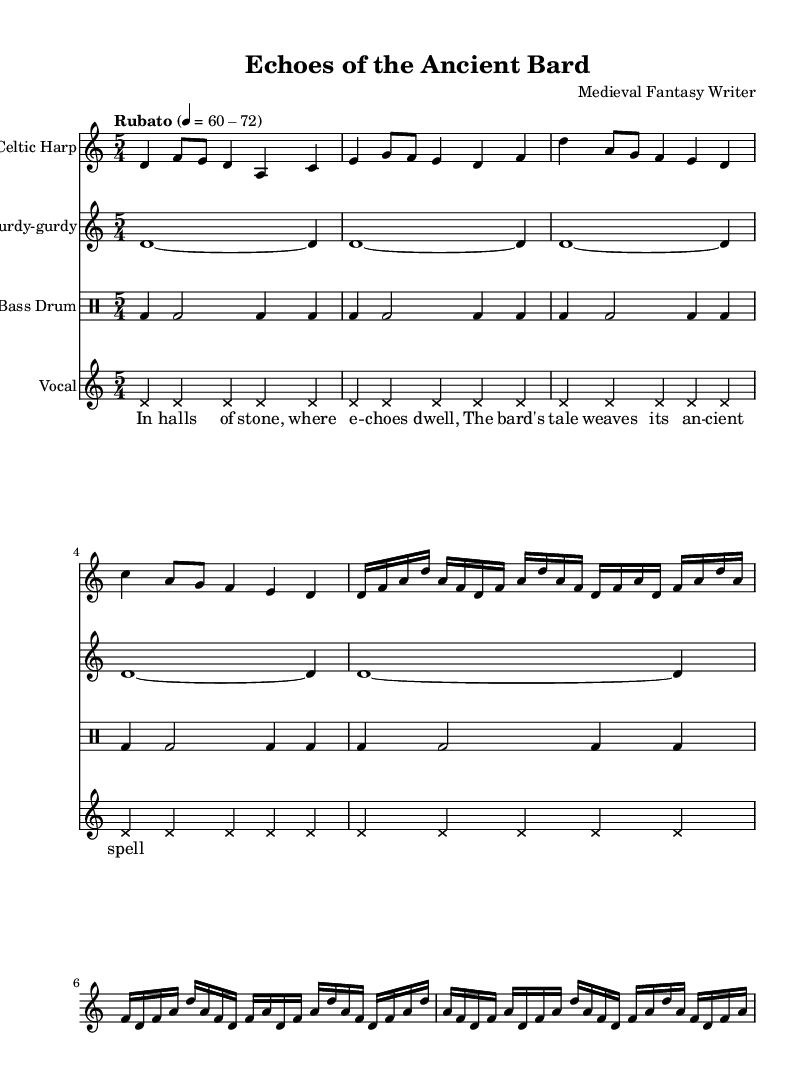What is the time signature of this music? The time signature is indicated at the beginning of the score, showing a “5/4” time signature. This means there are five beats in each measure, and a quarter note gets one beat.
Answer: 5/4 What is the key of this composition? The key signature is shown in the initial section of the music, which is D Dorian. This minor scale has a characteristic sound that is often associated with medieval music.
Answer: D Dorian What instrument plays the main melody? Analyzing the score reveals that the Celtic Harp is the primary instrument as it is notated first among the staff, containing the most melodic material.
Answer: Celtic Harp How many measures are in the vocal section? The vocal section consists of five measures, as indicated by counting the bars in the vocal staff from start to end.
Answer: 5 What type of musical notation is used for the vocals? The vocal notation uses 'cross' note heads as indicated by the override in the vocal part, indicating a style that differs from standard note heads often found in traditional vocal notations.
Answer: Cross How is the tempo indicated for this piece? The tempo instruction is "Rubato" and is marked with a range of beats per minute (60-72), affecting how the piece should be played expressively, allowing for fluctuations in timing.
Answer: Rubato What type of instrumentation is used in this score? The score features traditional and experimental instruments like Celtic Harp, Hurdy-gurdy, and Bass Drum, allowing a unique blend of ancient and avant-garde sounds in the composition.
Answer: Traditional and experimental 